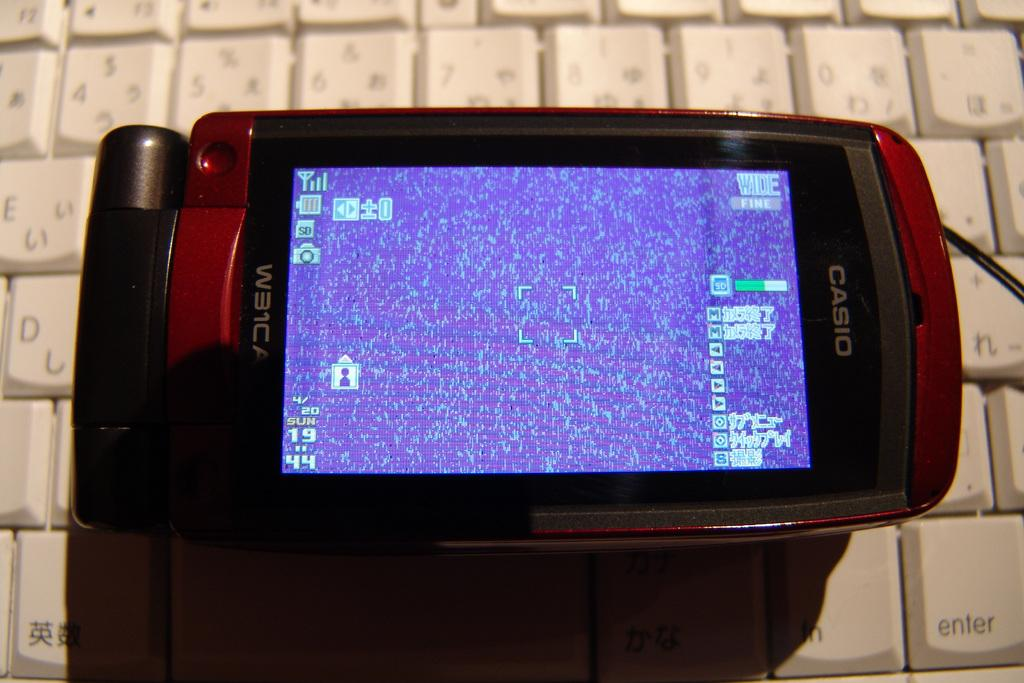<image>
Create a compact narrative representing the image presented. A Casio brand phone has a model number of W31CA. 